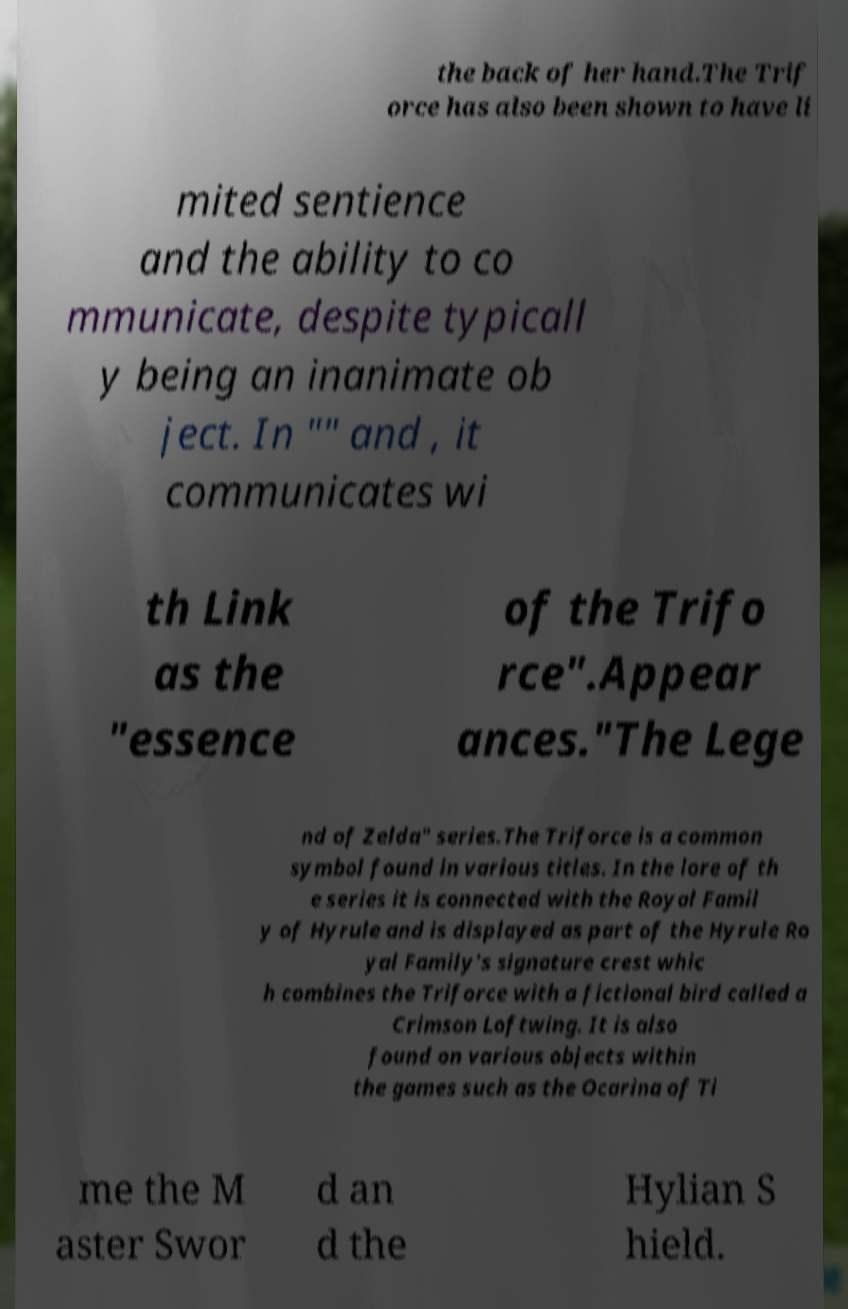Please identify and transcribe the text found in this image. the back of her hand.The Trif orce has also been shown to have li mited sentience and the ability to co mmunicate, despite typicall y being an inanimate ob ject. In "" and , it communicates wi th Link as the "essence of the Trifo rce".Appear ances."The Lege nd of Zelda" series.The Triforce is a common symbol found in various titles. In the lore of th e series it is connected with the Royal Famil y of Hyrule and is displayed as part of the Hyrule Ro yal Family's signature crest whic h combines the Triforce with a fictional bird called a Crimson Loftwing. It is also found on various objects within the games such as the Ocarina of Ti me the M aster Swor d an d the Hylian S hield. 